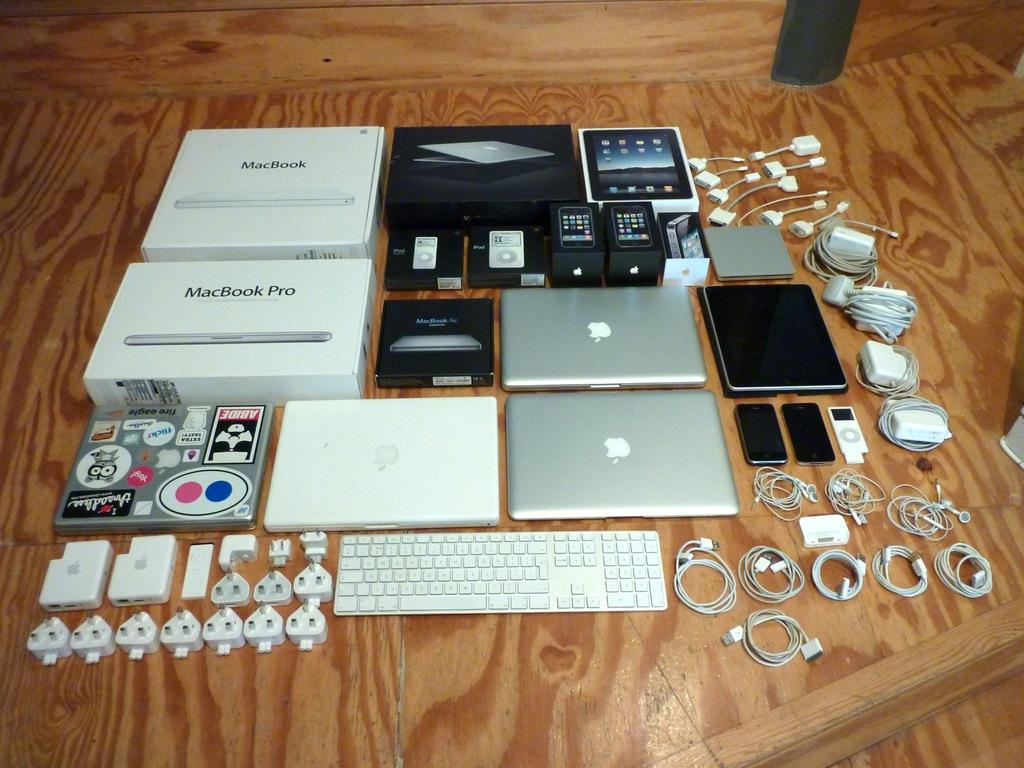<image>
Provide a brief description of the given image. An assortment of Apple products such as laptops, ipads and iphones are in a group with two MacBook Pro boxes. 